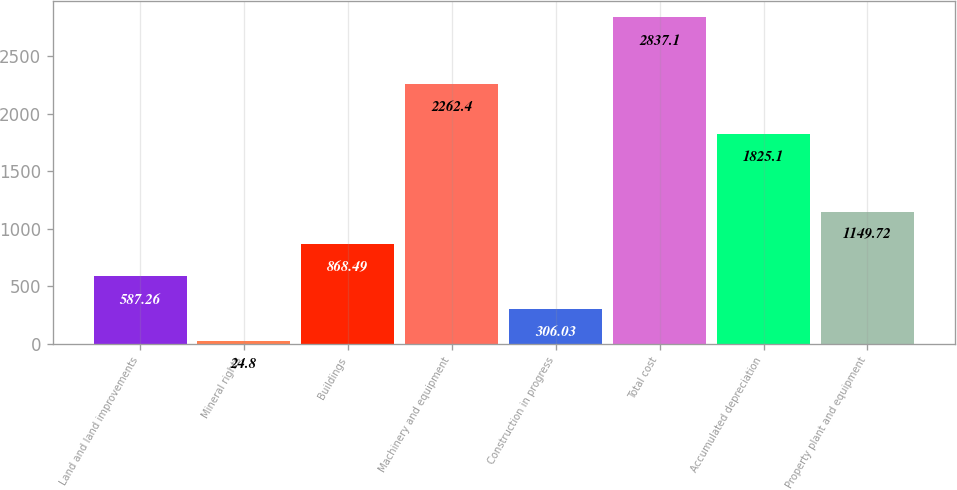Convert chart to OTSL. <chart><loc_0><loc_0><loc_500><loc_500><bar_chart><fcel>Land and land improvements<fcel>Mineral rights<fcel>Buildings<fcel>Machinery and equipment<fcel>Construction in progress<fcel>Total cost<fcel>Accumulated depreciation<fcel>Property plant and equipment<nl><fcel>587.26<fcel>24.8<fcel>868.49<fcel>2262.4<fcel>306.03<fcel>2837.1<fcel>1825.1<fcel>1149.72<nl></chart> 